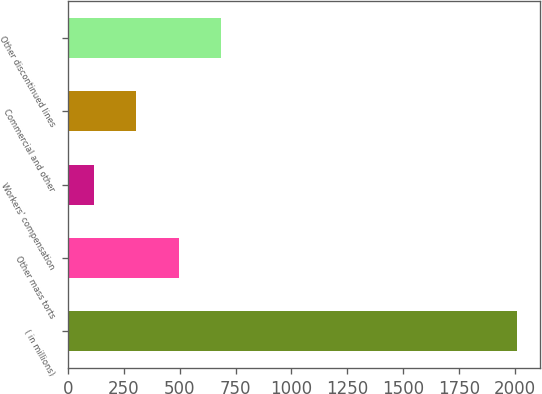Convert chart. <chart><loc_0><loc_0><loc_500><loc_500><bar_chart><fcel>( in millions)<fcel>Other mass torts<fcel>Workers' compensation<fcel>Commercial and other<fcel>Other discontinued lines<nl><fcel>2010<fcel>494.8<fcel>116<fcel>305.4<fcel>684.2<nl></chart> 